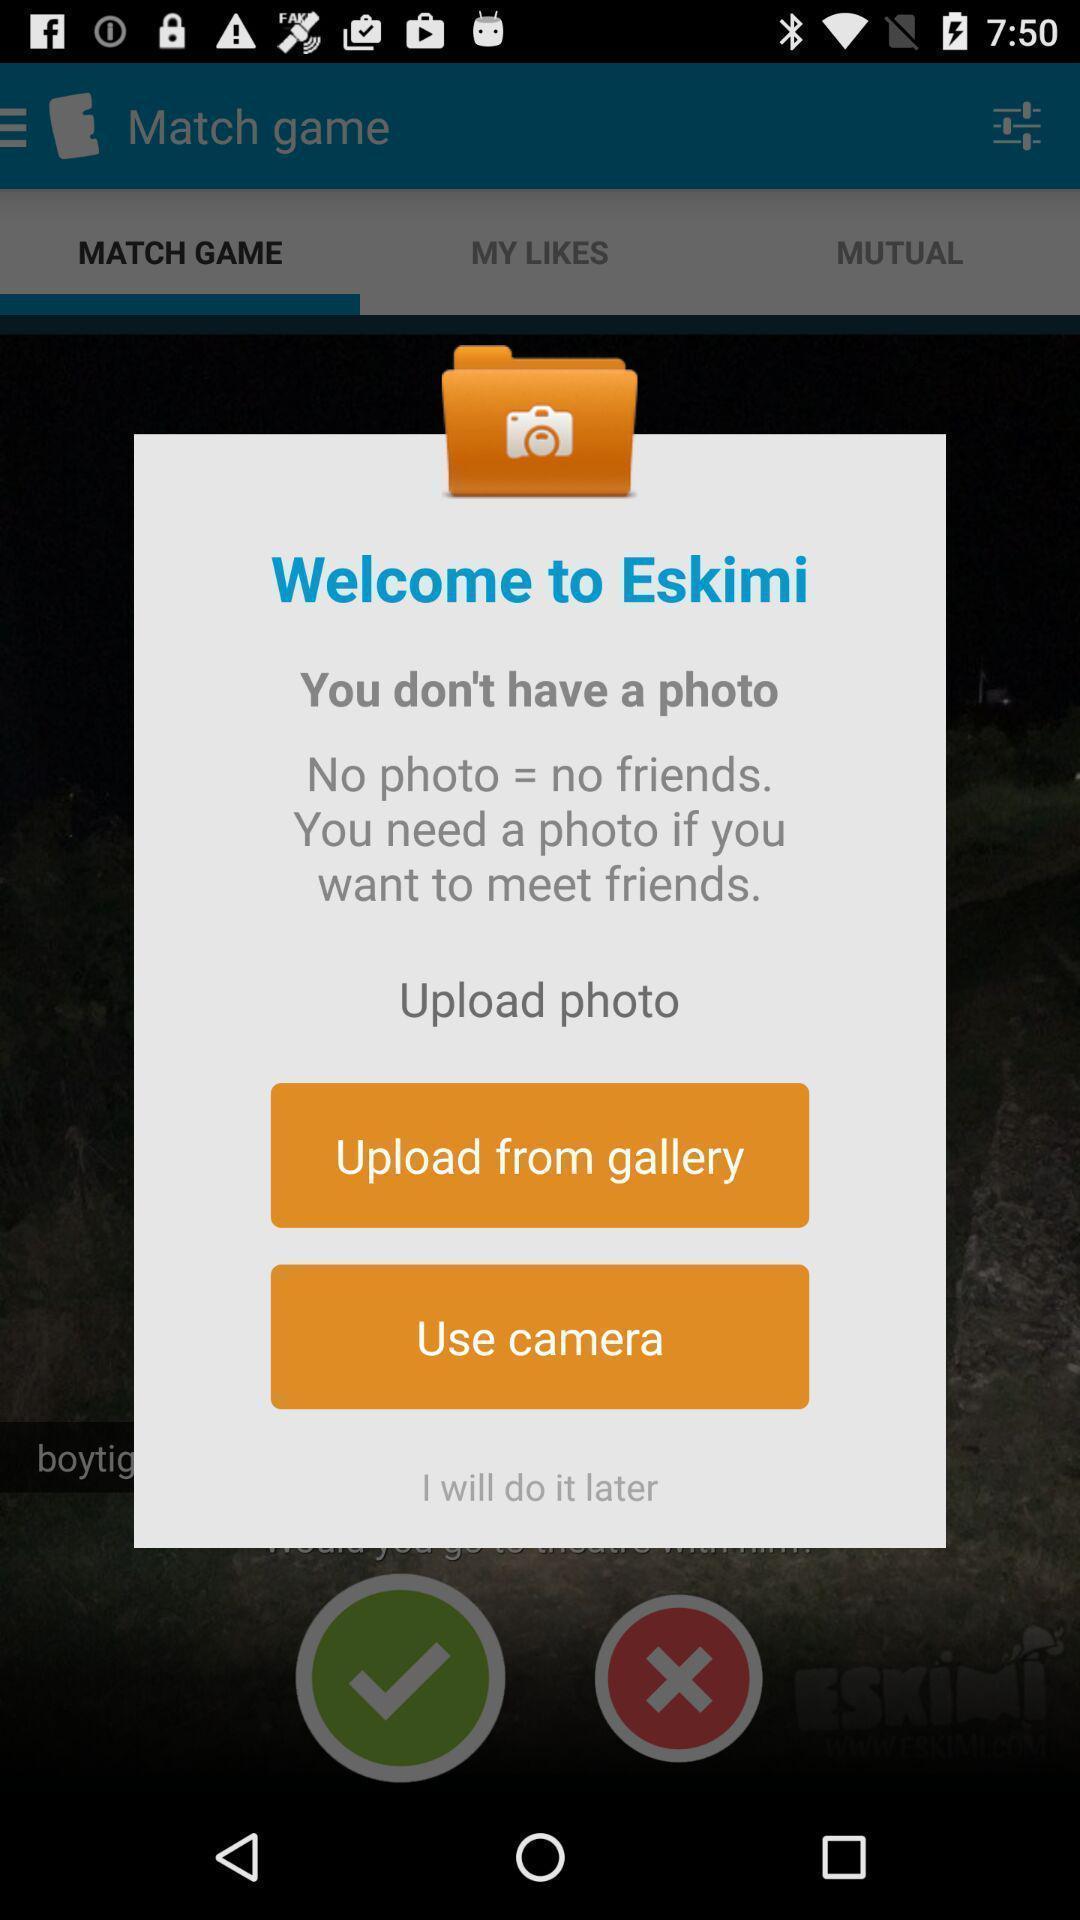Give me a narrative description of this picture. Welcome page. 